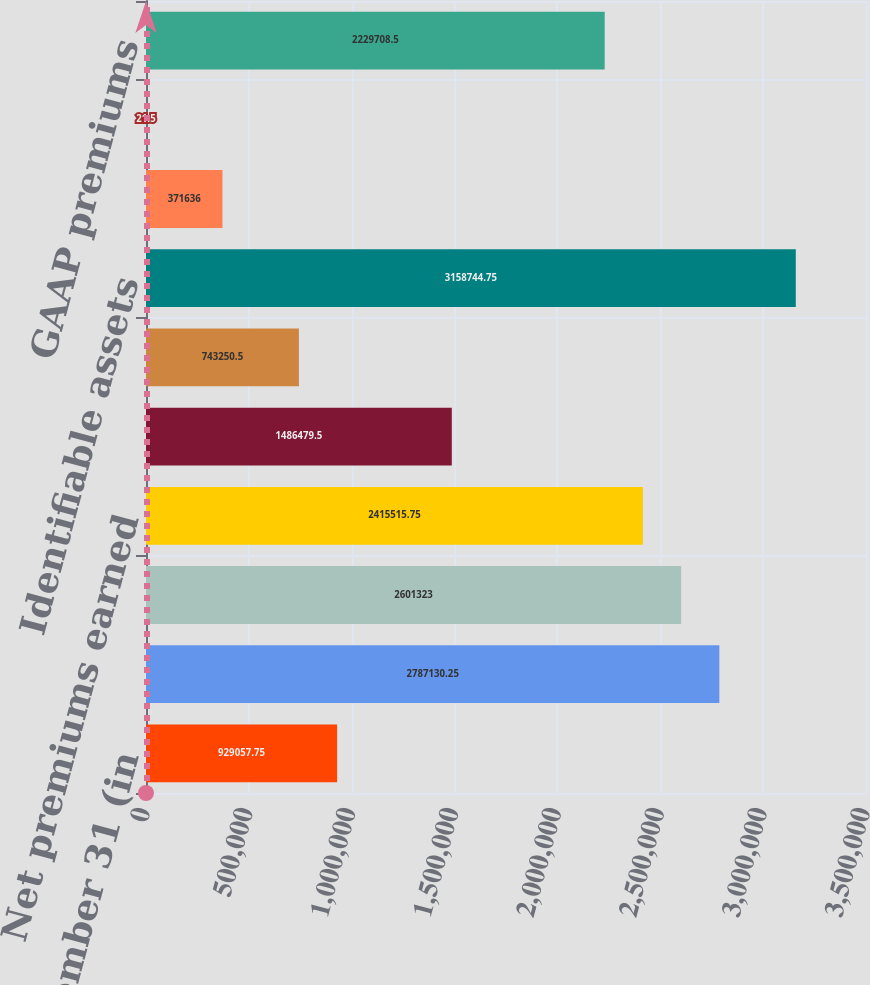<chart> <loc_0><loc_0><loc_500><loc_500><bar_chart><fcel>Years Ended December 31 (in<fcel>Gross premiums written<fcel>Net premiums written<fcel>Net premiums earned<fcel>Net investment income<fcel>Realized capital gains<fcel>Identifiable assets<fcel>Loss ratio<fcel>Expense ratio<fcel>GAAP premiums<nl><fcel>929058<fcel>2.78713e+06<fcel>2.60132e+06<fcel>2.41552e+06<fcel>1.48648e+06<fcel>743250<fcel>3.15874e+06<fcel>371636<fcel>21.5<fcel>2.22971e+06<nl></chart> 